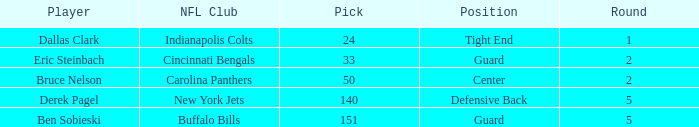What was the latest round that Derek Pagel was selected with a pick higher than 50? 5.0. 